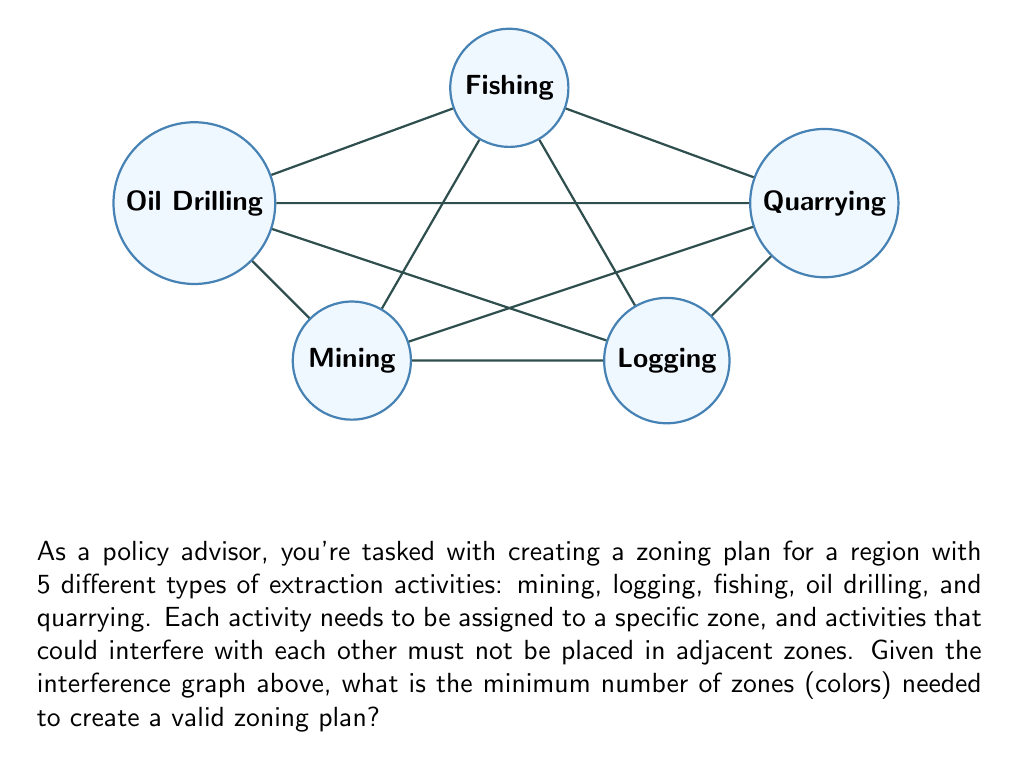Could you help me with this problem? To solve this problem, we need to use the graph coloring technique, where each color represents a zone. The minimum number of colors needed to color the graph such that no adjacent vertices have the same color is called the chromatic number.

Let's approach this step-by-step:

1) First, we need to identify the maximum degree (Δ) of the graph. The degree of a vertex is the number of edges connected to it.
   - Mining: 4 edges
   - Logging: 4 edges
   - Fishing: 4 edges
   - Oil Drilling: 3 edges
   - Quarrying: 3 edges
   
   The maximum degree Δ = 4.

2) According to Brooks' theorem, for a connected, undirected graph that is not a complete graph or an odd cycle, the chromatic number χ(G) ≤ Δ.

3) Our graph is not a complete graph (it would need 10 edges to be complete, but it only has 8), and it's not an odd cycle. Therefore, Brooks' theorem applies.

4) This means that χ(G) ≤ 4.

5) Now, let's try to color the graph with 4 colors:
   - Assign color 1 to Mining
   - Assign color 2 to Logging
   - Assign color 3 to Fishing
   - Assign color 4 to Oil Drilling
   - We can then assign color 2 to Quarrying, as it's not adjacent to Logging

6) This coloring is valid as no adjacent vertices have the same color.

Therefore, the minimum number of zones (colors) needed is 4.
Answer: 4 zones 